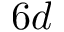<formula> <loc_0><loc_0><loc_500><loc_500>6 d</formula> 